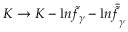<formula> <loc_0><loc_0><loc_500><loc_500>K \rightarrow K - { l n } { \tilde { f } } _ { \gamma } - { l n } { \bar { \tilde { f } } _ { \gamma } }</formula> 